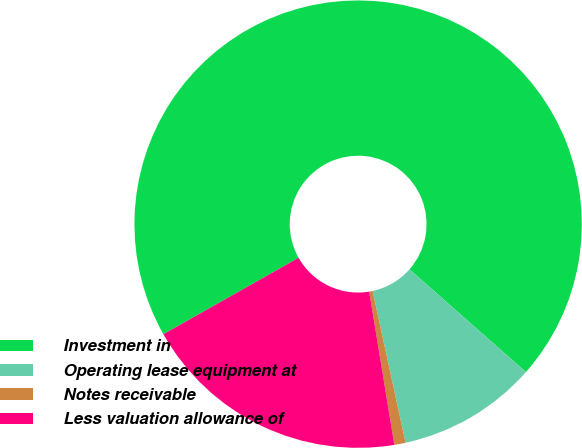Convert chart to OTSL. <chart><loc_0><loc_0><loc_500><loc_500><pie_chart><fcel>Investment in<fcel>Operating lease equipment at<fcel>Notes receivable<fcel>Less valuation allowance of<nl><fcel>69.69%<fcel>10.1%<fcel>0.81%<fcel>19.4%<nl></chart> 